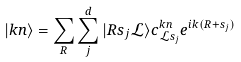Convert formula to latex. <formula><loc_0><loc_0><loc_500><loc_500>| k n \rangle = \sum _ { R } \sum _ { j } ^ { d } | R s _ { j } \mathcal { L } \rangle c _ { \mathcal { L } s _ { j } } ^ { k n } e ^ { i k ( R + s _ { j } ) }</formula> 